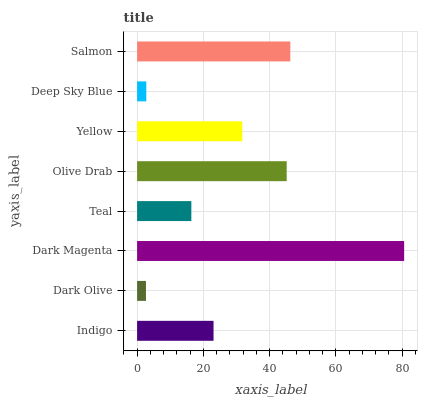Is Dark Olive the minimum?
Answer yes or no. Yes. Is Dark Magenta the maximum?
Answer yes or no. Yes. Is Dark Magenta the minimum?
Answer yes or no. No. Is Dark Olive the maximum?
Answer yes or no. No. Is Dark Magenta greater than Dark Olive?
Answer yes or no. Yes. Is Dark Olive less than Dark Magenta?
Answer yes or no. Yes. Is Dark Olive greater than Dark Magenta?
Answer yes or no. No. Is Dark Magenta less than Dark Olive?
Answer yes or no. No. Is Yellow the high median?
Answer yes or no. Yes. Is Indigo the low median?
Answer yes or no. Yes. Is Dark Olive the high median?
Answer yes or no. No. Is Teal the low median?
Answer yes or no. No. 